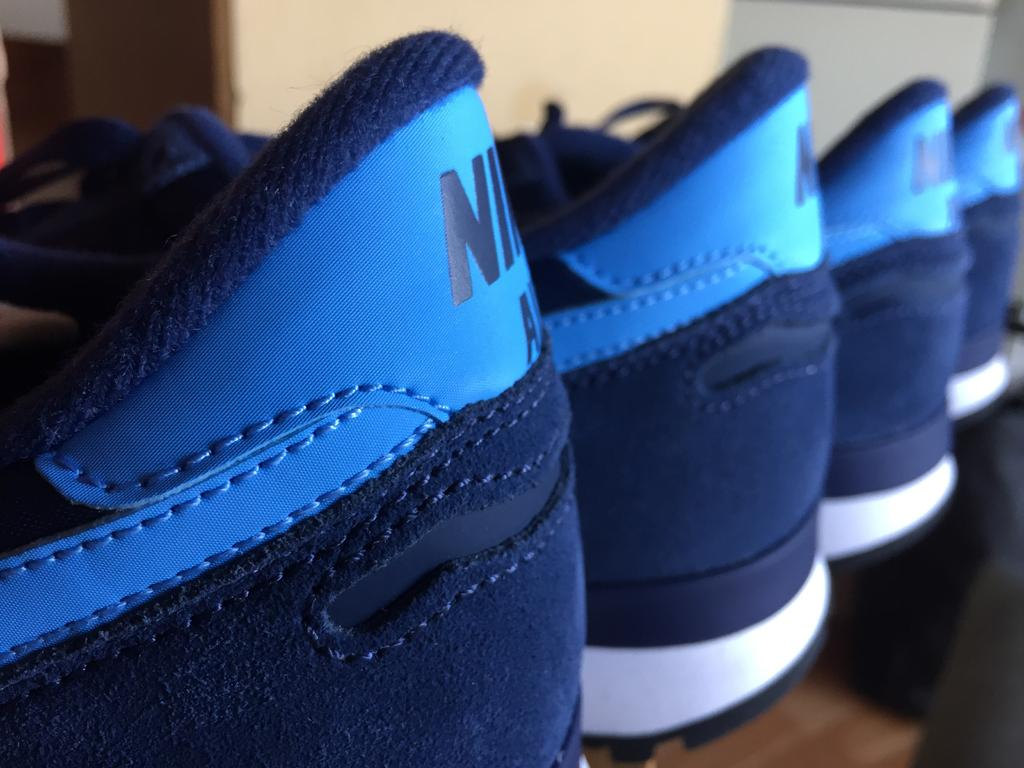How many shoes are visible in the image? There are four blue color shoes in the image. What is the surface on which the shoes are placed? The shoes are on a wooden surface. What can be seen in the background of the image? There is a wall in the background of the image. What type of clock is hanging on the wall in the image? There is no clock visible in the image; only the shoes and wooden surface are present. Can you see a zebra in the image? No, there is no zebra present in the image. 